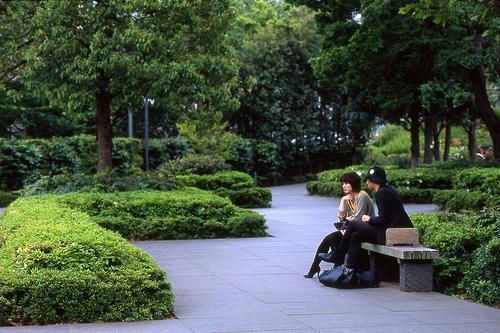How many people are there?
Give a very brief answer. 2. How many people are pictured?
Give a very brief answer. 2. How many people are in the picture?
Give a very brief answer. 2. How many benches are in the picture?
Give a very brief answer. 1. 